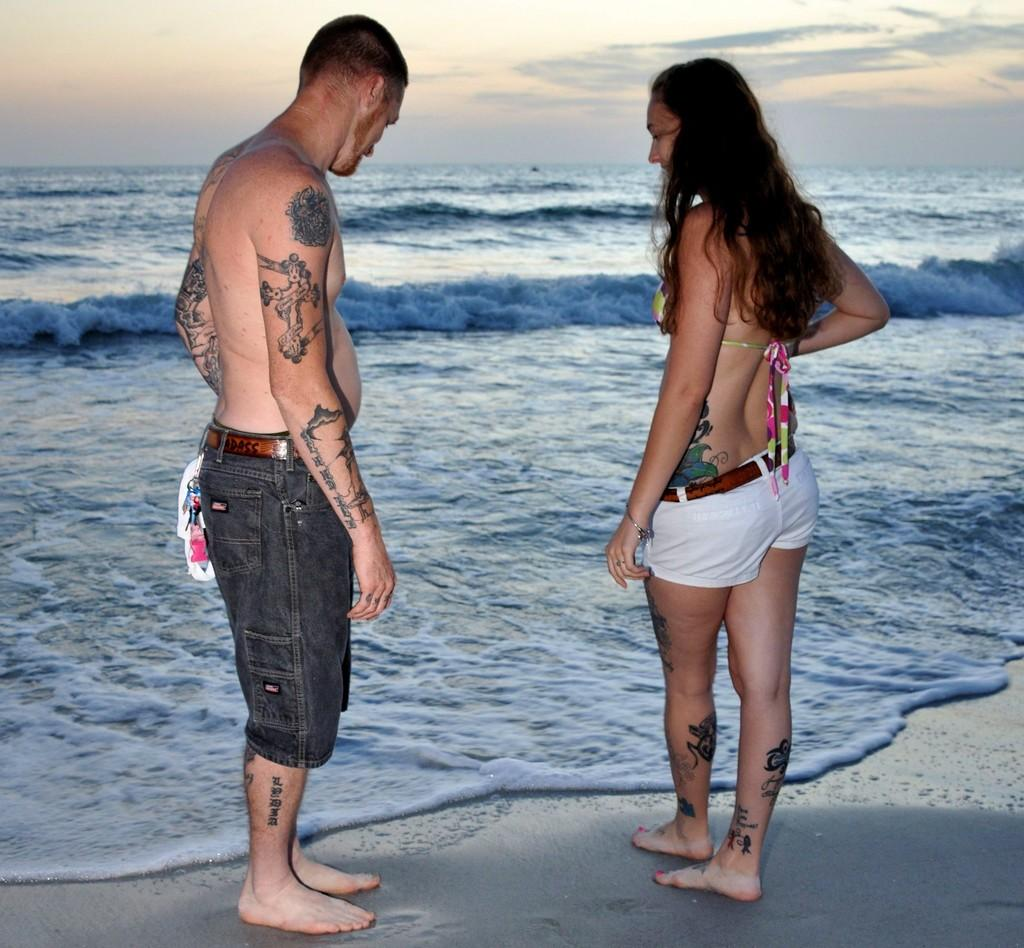How many people are in the image? There are 2 people in the image. Where are the people standing? The people are standing on the sand. What can be seen on the people's bodies? The people have tattoos on their bodies. What else is visible in the image besides the people? There is water and the sky visible in the image. What type of creature can be seen swimming in the water in the image? There is no creature visible in the water in the image. What letters are written on the sand in the image? There are no letters written on the sand in the image. 